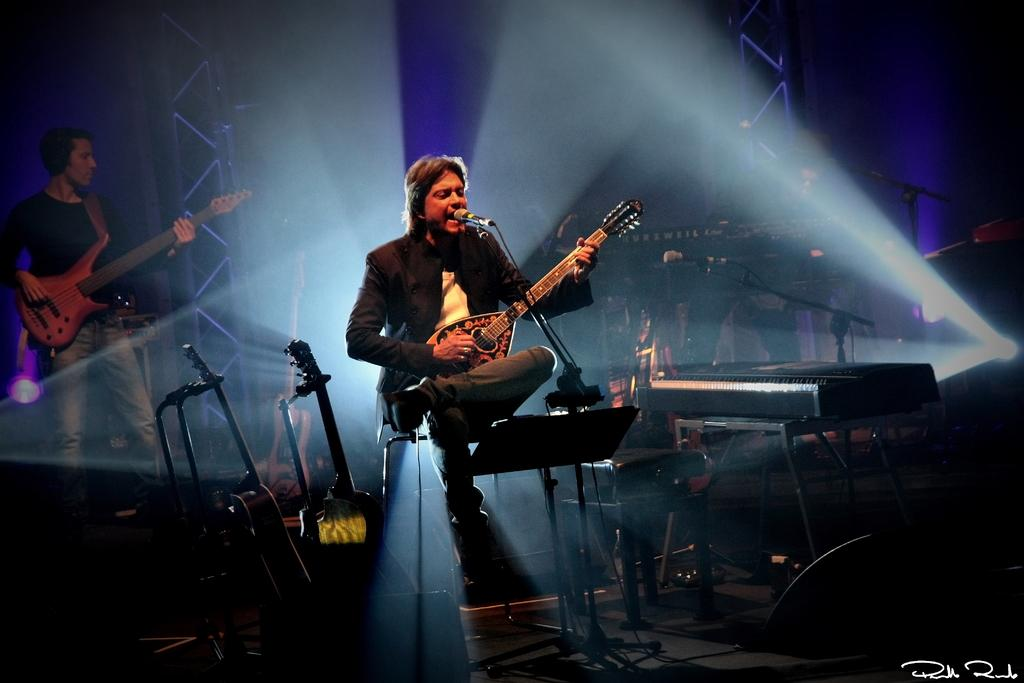What is the man in the image doing while sitting on a chair? The man is playing a guitar. Is there any equipment near the man while he plays the guitar? Yes, he is playing the guitar near a microphone. Can you describe the other person in the image? There is another man on the left side of the image, and he is also playing a guitar. Where is the second man located in the image? The second man is on a stage. What type of pie is being served on the stage in the image? There is no pie present in the image; it features two men playing guitars on a stage. 